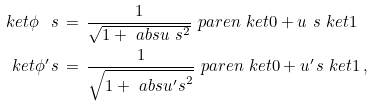<formula> <loc_0><loc_0><loc_500><loc_500>\ k e t { \phi _ { \ } s } \, & = \, \frac { 1 } { \sqrt { 1 + \ a b s { u _ { \ } s } ^ { 2 } } } \ p a r e n { \ k e t { 0 } + u _ { \ } s \ k e t { 1 } } \\ \ k e t { \phi ^ { \prime } _ { \ } s } \, & = \, \frac { 1 } { \sqrt { 1 + \ a b s { u ^ { \prime } _ { \ } s } ^ { 2 } } } \ p a r e n { \ k e t { 0 } + u ^ { \prime } _ { \ } s \ k e t { 1 } } \, ,</formula> 